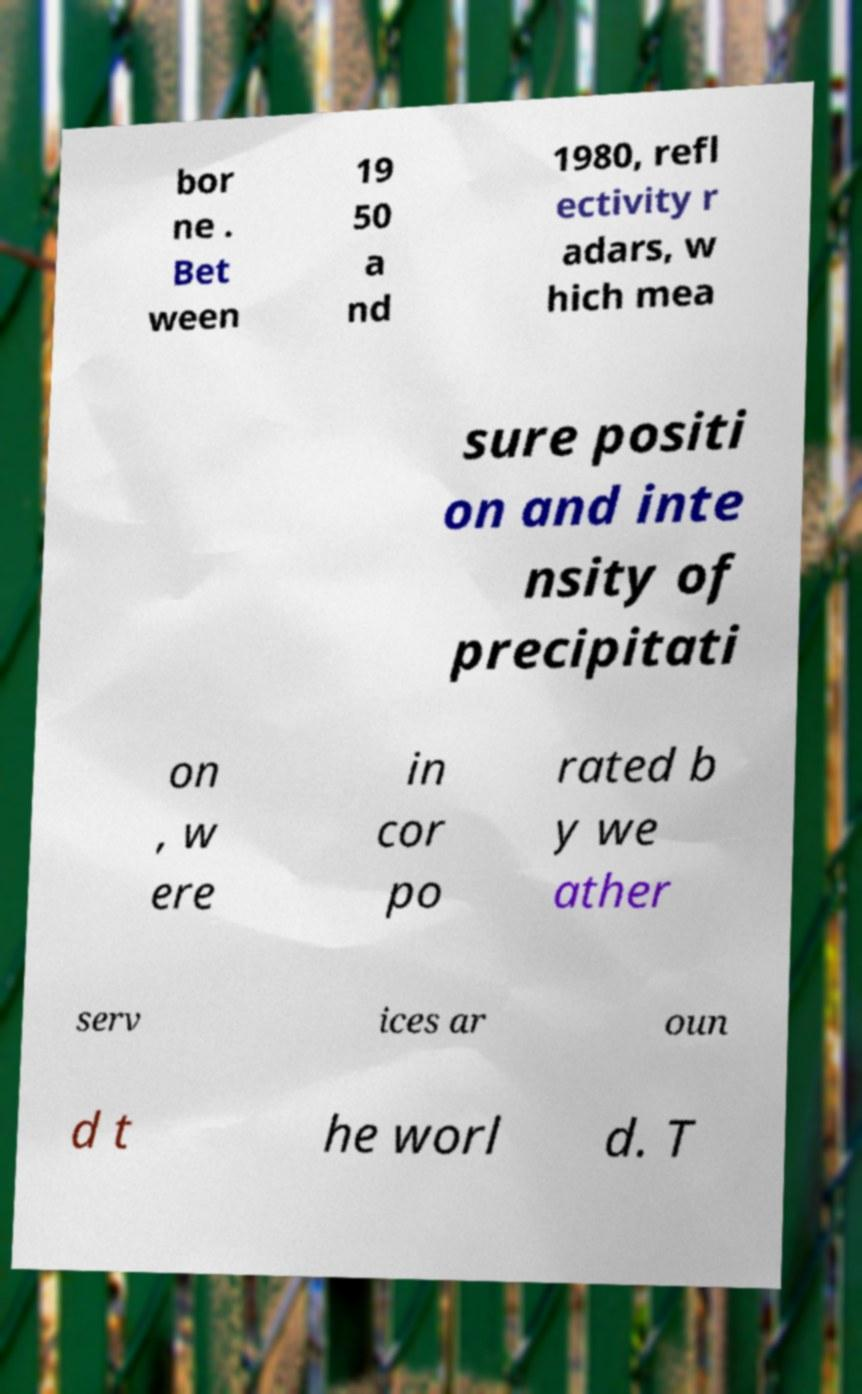I need the written content from this picture converted into text. Can you do that? bor ne . Bet ween 19 50 a nd 1980, refl ectivity r adars, w hich mea sure positi on and inte nsity of precipitati on , w ere in cor po rated b y we ather serv ices ar oun d t he worl d. T 